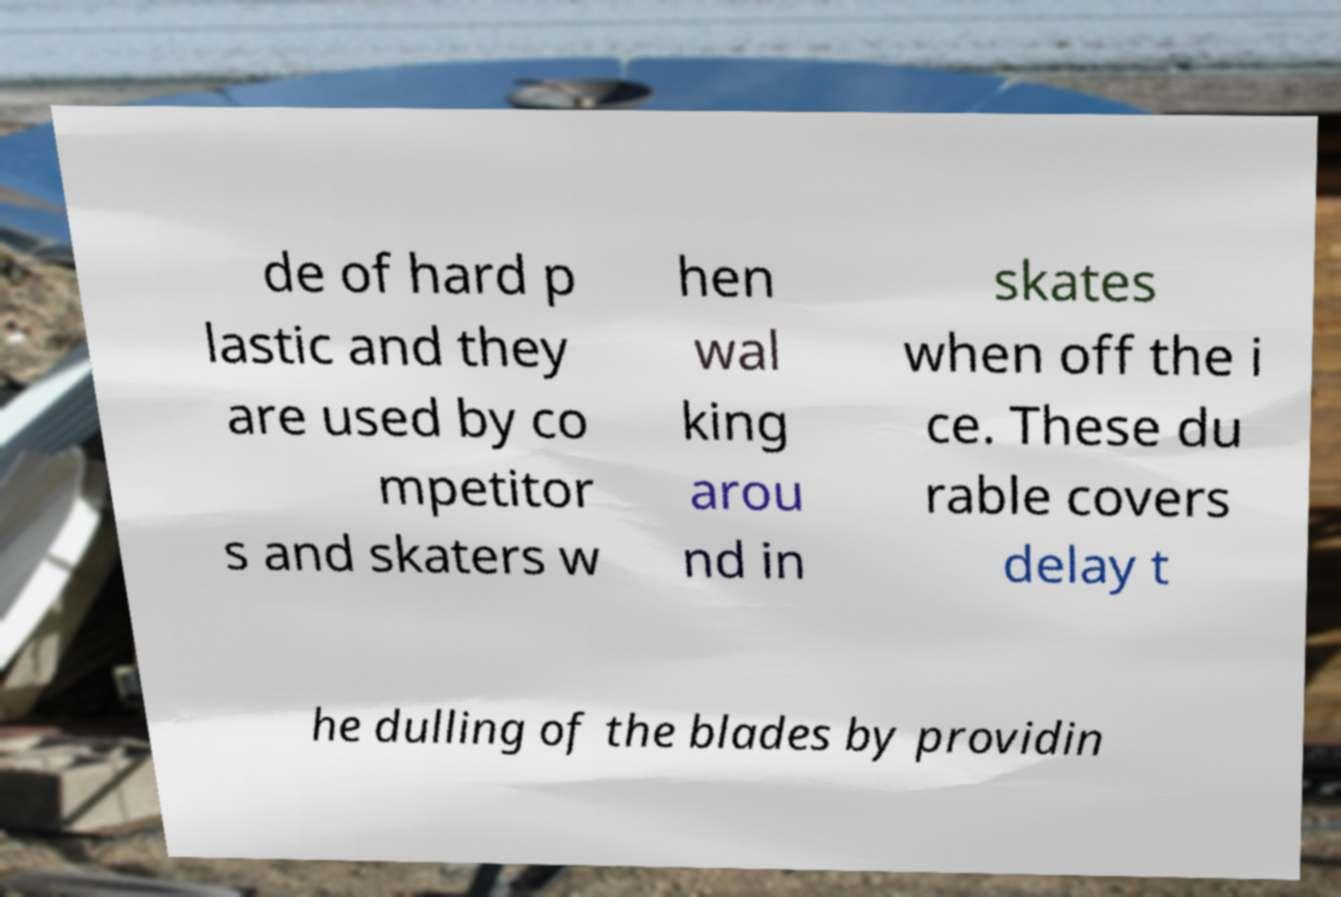There's text embedded in this image that I need extracted. Can you transcribe it verbatim? de of hard p lastic and they are used by co mpetitor s and skaters w hen wal king arou nd in skates when off the i ce. These du rable covers delay t he dulling of the blades by providin 